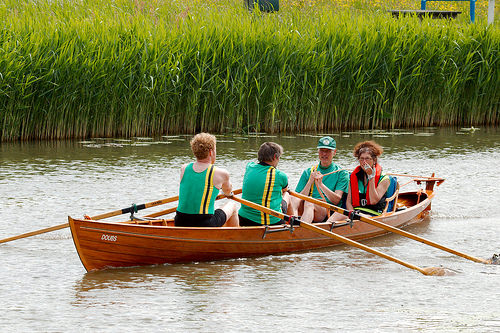<image>
Can you confirm if the canoe is to the right of the water? No. The canoe is not to the right of the water. The horizontal positioning shows a different relationship. Is the man in front of the man? No. The man is not in front of the man. The spatial positioning shows a different relationship between these objects. 